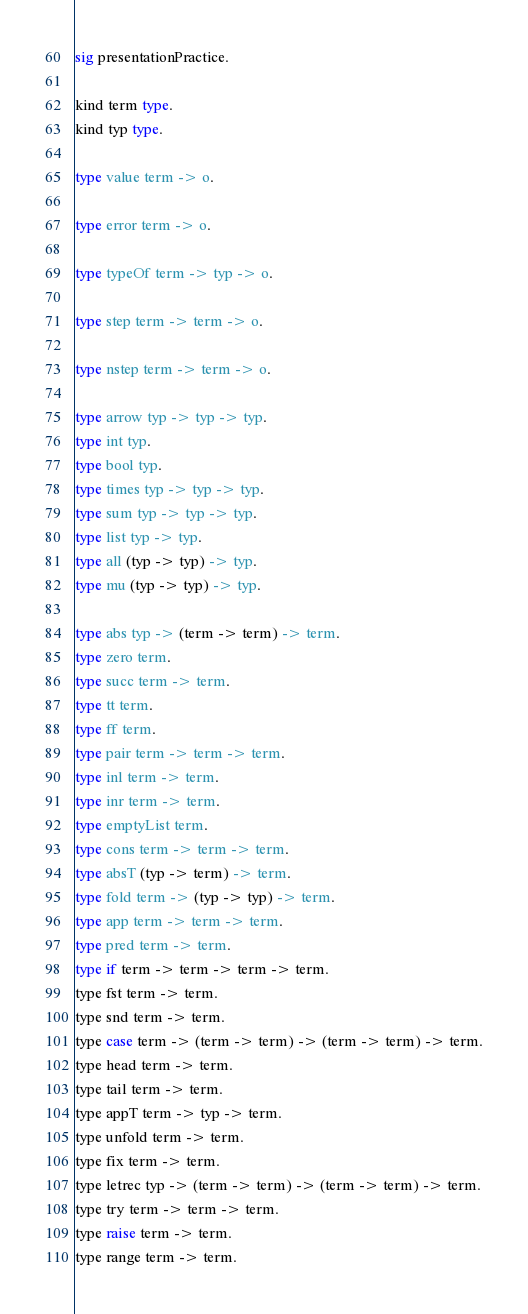<code> <loc_0><loc_0><loc_500><loc_500><_SML_>sig presentationPractice.

kind term type.
kind typ type.

type value term -> o.

type error term -> o.

type typeOf term -> typ -> o.

type step term -> term -> o.

type nstep term -> term -> o.

type arrow typ -> typ -> typ.
type int typ.
type bool typ.
type times typ -> typ -> typ.
type sum typ -> typ -> typ.
type list typ -> typ.
type all (typ -> typ) -> typ.
type mu (typ -> typ) -> typ.

type abs typ -> (term -> term) -> term.
type zero term.
type succ term -> term.
type tt term.
type ff term.
type pair term -> term -> term.
type inl term -> term.
type inr term -> term.
type emptyList term.
type cons term -> term -> term.
type absT (typ -> term) -> term.
type fold term -> (typ -> typ) -> term.
type app term -> term -> term.
type pred term -> term.
type if term -> term -> term -> term.
type fst term -> term.
type snd term -> term.
type case term -> (term -> term) -> (term -> term) -> term.
type head term -> term.
type tail term -> term.
type appT term -> typ -> term.
type unfold term -> term.
type fix term -> term.
type letrec typ -> (term -> term) -> (term -> term) -> term.
type try term -> term -> term.
type raise term -> term.
type range term -> term.</code> 